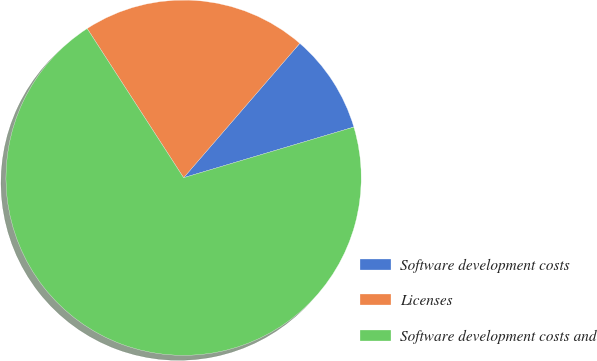<chart> <loc_0><loc_0><loc_500><loc_500><pie_chart><fcel>Software development costs<fcel>Licenses<fcel>Software development costs and<nl><fcel>9.05%<fcel>20.48%<fcel>70.47%<nl></chart> 